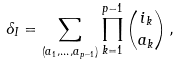Convert formula to latex. <formula><loc_0><loc_0><loc_500><loc_500>\delta _ { I } = \sum _ { ( a _ { 1 } , \dots , a _ { p - 1 } ) } \prod _ { k = 1 } ^ { p - 1 } \binom { i _ { k } } { a _ { k } } \, ,</formula> 